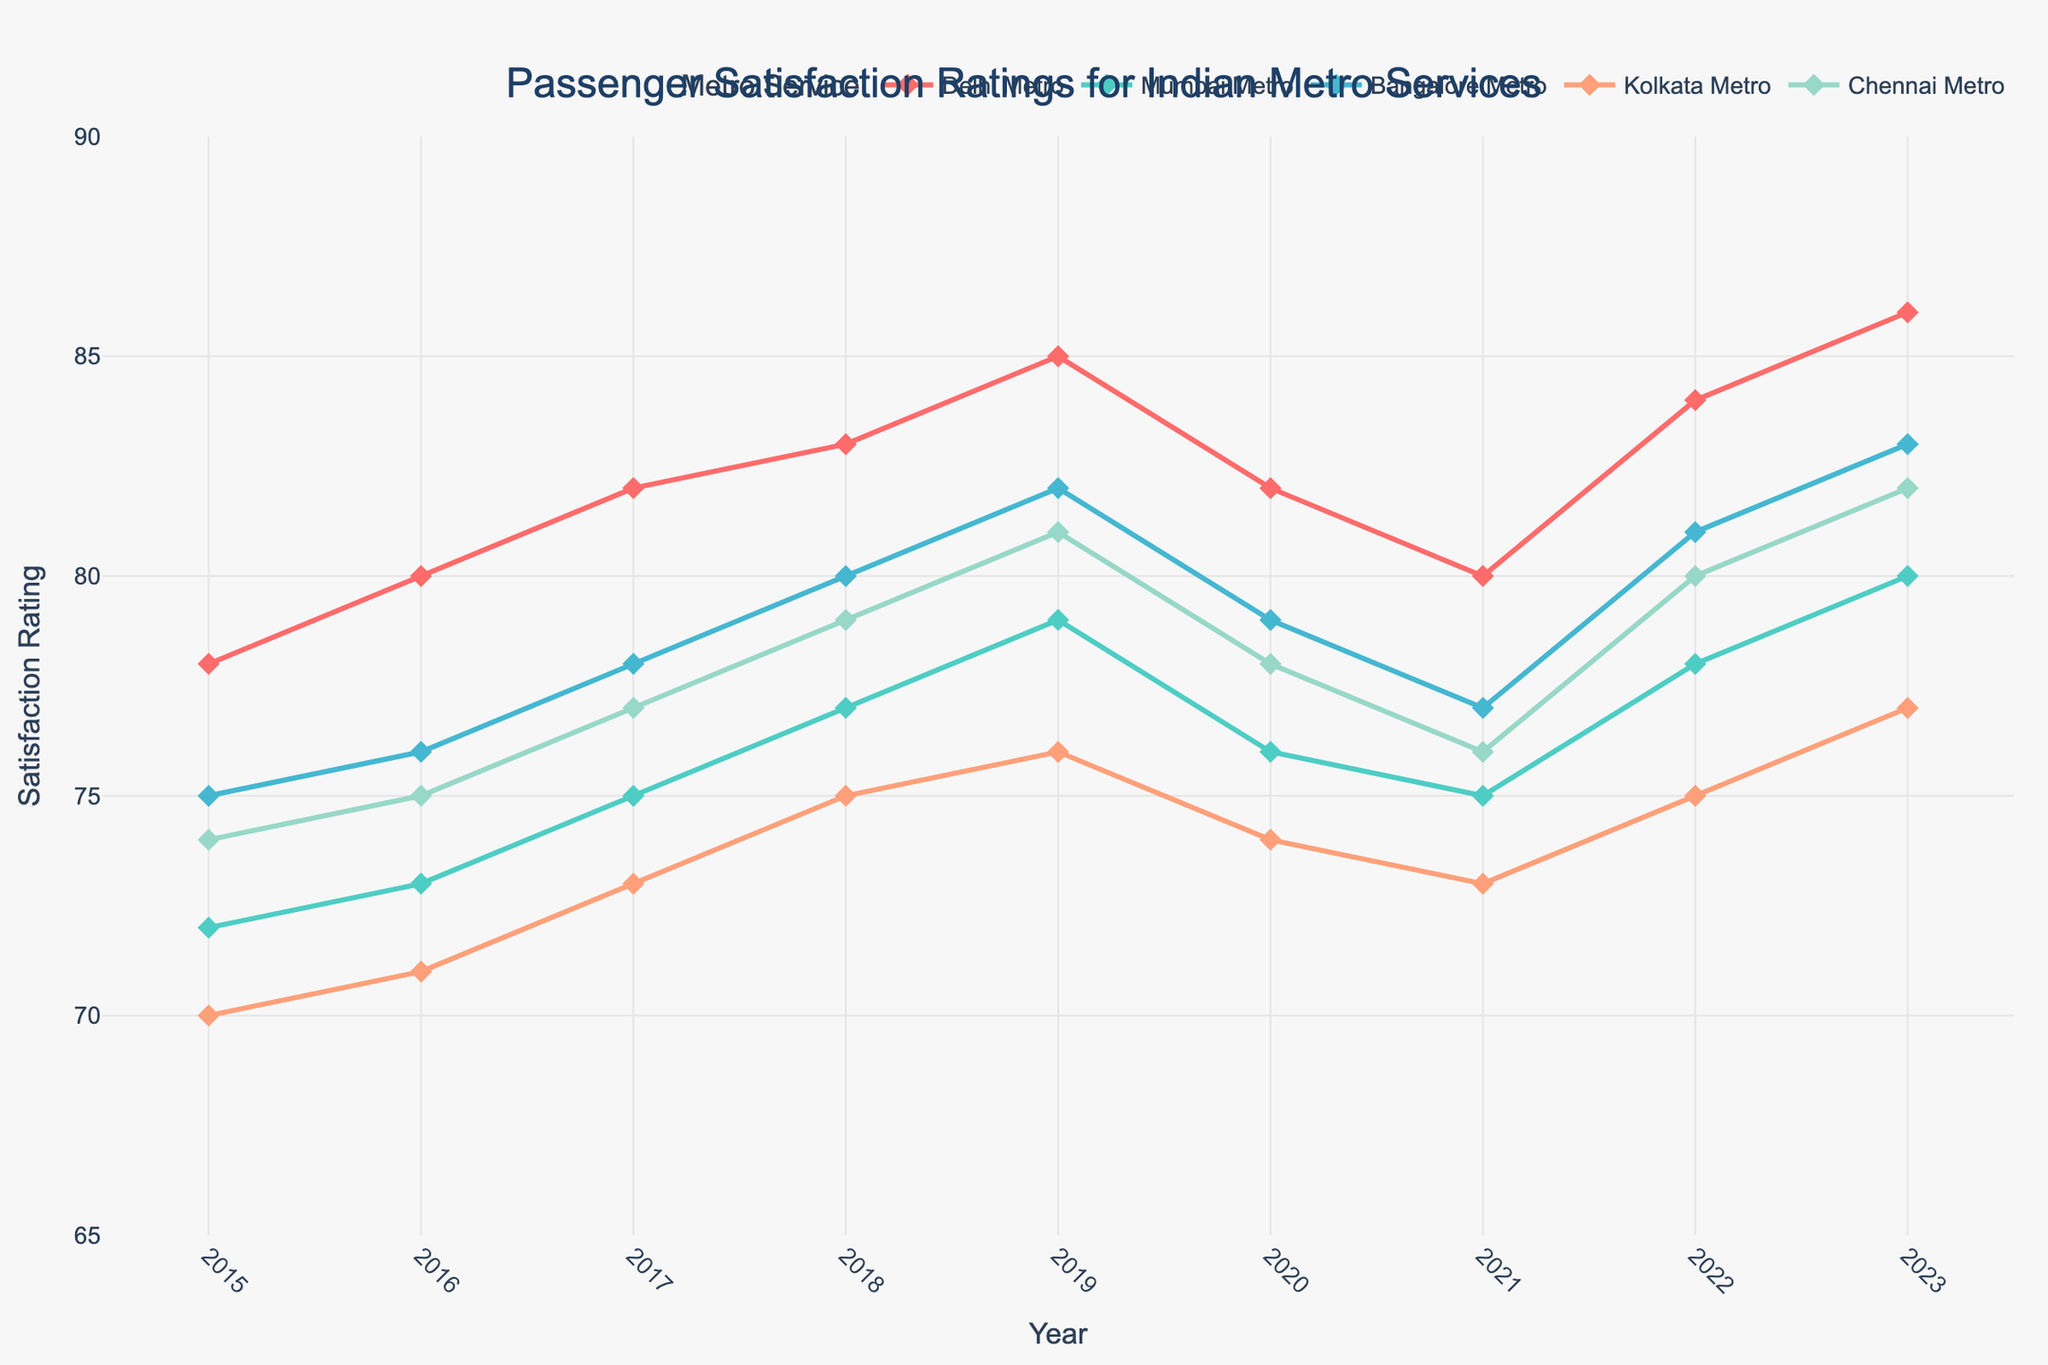how did the satisfaction rating for Delhi Metro change between 2015 and 2023? To determine this, we look at the initial and final values for the Delhi Metro in the chart. The satisfaction rating in 2015 was 78, and in 2023 it was 86. Therefore, the change in the rating is 86 - 78.
Answer: 8 which city's metro showed the largest increase in satisfaction rating from 2015 to 2023? To find this, we calculate the increase for each city. Delhi: 86-78 = 8, Mumbai: 80-72 = 8, Bangalore: 83-75 = 8, Kolkata: 77-70 = 7, Chennai: 82-74 = 8. Delhi, Mumbai, Bangalore, and Chennai all increased by 8 points.
Answer: Delhi, Mumbai, Bangalore, Chennai which year saw the highest satisfaction rating for Kolkata Metro? We observe the ratings for Kolkata Metro each year and identify the highest value. The highest rating for Kolkata Metro is 77, which occurred in 2023.
Answer: 2023 how did the satisfaction rating for Mumbai Metro change after 2019? Look at the satisfaction ratings for Mumbai Metro from 2019 onwards. In 2019, it was 79; in 2020, it was 76; in 2021, it was 75; in 2022, it was 78; and in 2023, it was 80. Thus, the trend was a drop from 2019 to 2021, followed by an increase in 2022 and 2023.
Answer: Decreased until 2021, then increased how many years did Delhi Metro have satisfaction ratings above 80? We count the number of years Delhi Metro's ratings were above 80. The ratings above 80 occurred in 2017, 2018, 2019, 2022, and 2023. That's 5 years.
Answer: 5 which metro had the least fluctuating satisfaction ratings from 2015 to 2023? We check the consistency of ratings for all metros. Fluctuations are assessed by the range between the highest and lowest ratings. Delhi: 86-78=8, Mumbai: 80-72=8, Bangalore: 83-75=8, Kolkata: 77-70=7, Chennai: 82-74=8. Kolkata Metro shows the least fluctuation with a range of 7.
Answer: Kolkata what was the average satisfaction rating for Bangalore Metro from 2015 to 2023? To find the average rating, we add all the ratings from 2015 to 2023 and divide by the number of years (9). Sum of ratings = 75+76+78+80+82+79+77+81+83 = 711. Average = 711/9.
Answer: 79 which metro experienced a drop in satisfaction ratings in 2020? We compare the ratings in 2019 and 2020 for each metro. The metros where the rating dropped in 2020 are Delhi (85 to 82), Mumbai (79 to 76), Bangalore (82 to 79), Kolkata (76 to 74), and Chennai (81 to 78).
Answer: Delhi, Mumbai, Bangalore, Kolkata, Chennai which year did Chennai Metro first achieve a satisfaction rating of 80 or more? We look for the earliest year when Chennai's satisfaction rating was 80 or higher. The first instance is in 2022, where the rating reached 80.
Answer: 2022 which metros had a satisfaction rating of exactly 77 in any of the plotted years? We review the plotted years for each metro to find when they had a rating of 77. In 2017, Mumbai Metro had 77. In 2021, Bangalore Metro had 77. In 2023, Kolkata Metro had 77.
Answer: Mumbai, Bangalore, Kolkata 